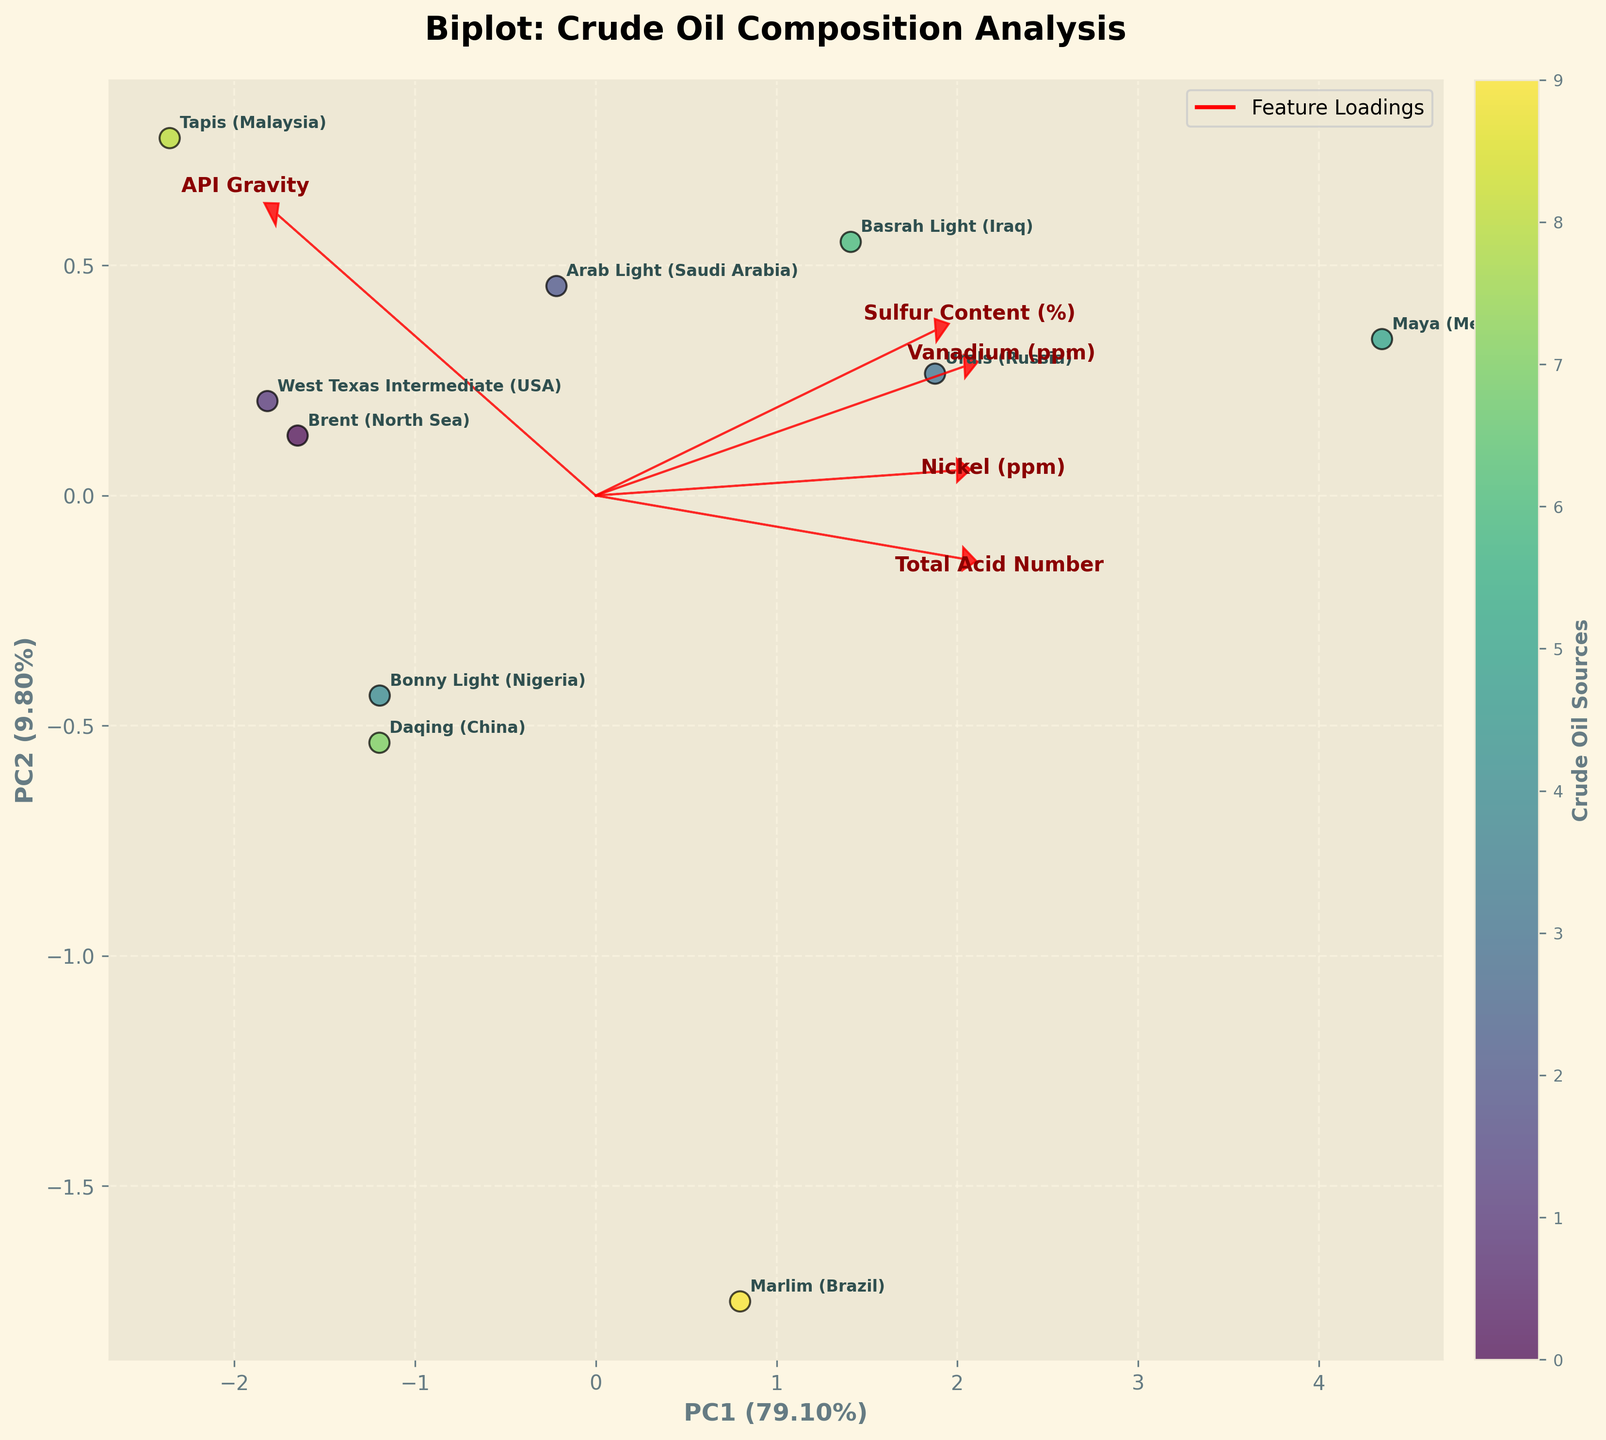Which crude oil source has the highest sulfur content? By looking at the plot, find the point with the highest score along the arrow/direction labeled "Sulfur Content (%)".
Answer: Maya (Mexico) Which feature loading arrows align most closely with each other? Examine the directions of the arrows to see which are pointing in similar ways. "Nickel (ppm)" and "Vanadium (ppm)" both point in almost the same direction.
Answer: Nickel (ppm) and Vanadium (ppm) Which crude oil sources have the lowest API Gravity? Look at the oil sources positioned at the lowest values along the axis labeled "API Gravity" (in the direction of the feature arrow).
Answer: Marlim (Brazil) and Maya (Mexico) Are there any crude oil sources that have both low sulfur content and high API gravity? Check the plot for oil sources that are close to the high API gravity end and near the low sulfur content side of the plot.
Answer: Tapis (Malaysia) How is the 'Total Acid Number' represented in the plot? Observe the direction of the feature arrow labeled "Total Acid Number" to understand how this feature is aligned compared to others in the plot.
Answer: As a red arrow pointing to the right-bottom direction Which component explains more variance in crude oil composition – PC1 or PC2? Check the axis labels, which should have the variance explained percentages in parentheses next to 'PC1' and 'PC2'.
Answer: PC1 What is the approximate relationship between high Nickel content and API gravity? Look at the alignment of the "Nickel (ppm)" arrow relative to the "API Gravity" direction. They point in somewhat opposite directions.
Answer: Inversely related Which crude oil source appears most correlated with high 'Vanadium' and 'Nickel' content? Find the point closest to the arrows labeled 'Vanadium (ppm)' and 'Nickel (ppm)'.
Answer: Urals (Russia) Are there any crude oil sources that cluster closely together in terms of composition? Look for groups of points that are closely positioned in the plot. Brent (North Sea), West Texas Intermediate (USA), Bonny Light (Nigeria), and Daqing (China) form a cluster.
Answer: Brent (North Sea), West Texas Intermediate (USA), Bonny Light (Nigeria), and Daqing (China) What does a point’s position on the biplot indicate about its crude oil source composition? A point's position is determined by PCA to maximize the explained variance along PC1 and PC2, influenced by how each feature's loading combines to place it within the plot space.
Answer: The specific composition in terms of the features in the direction and length of respective arrows 